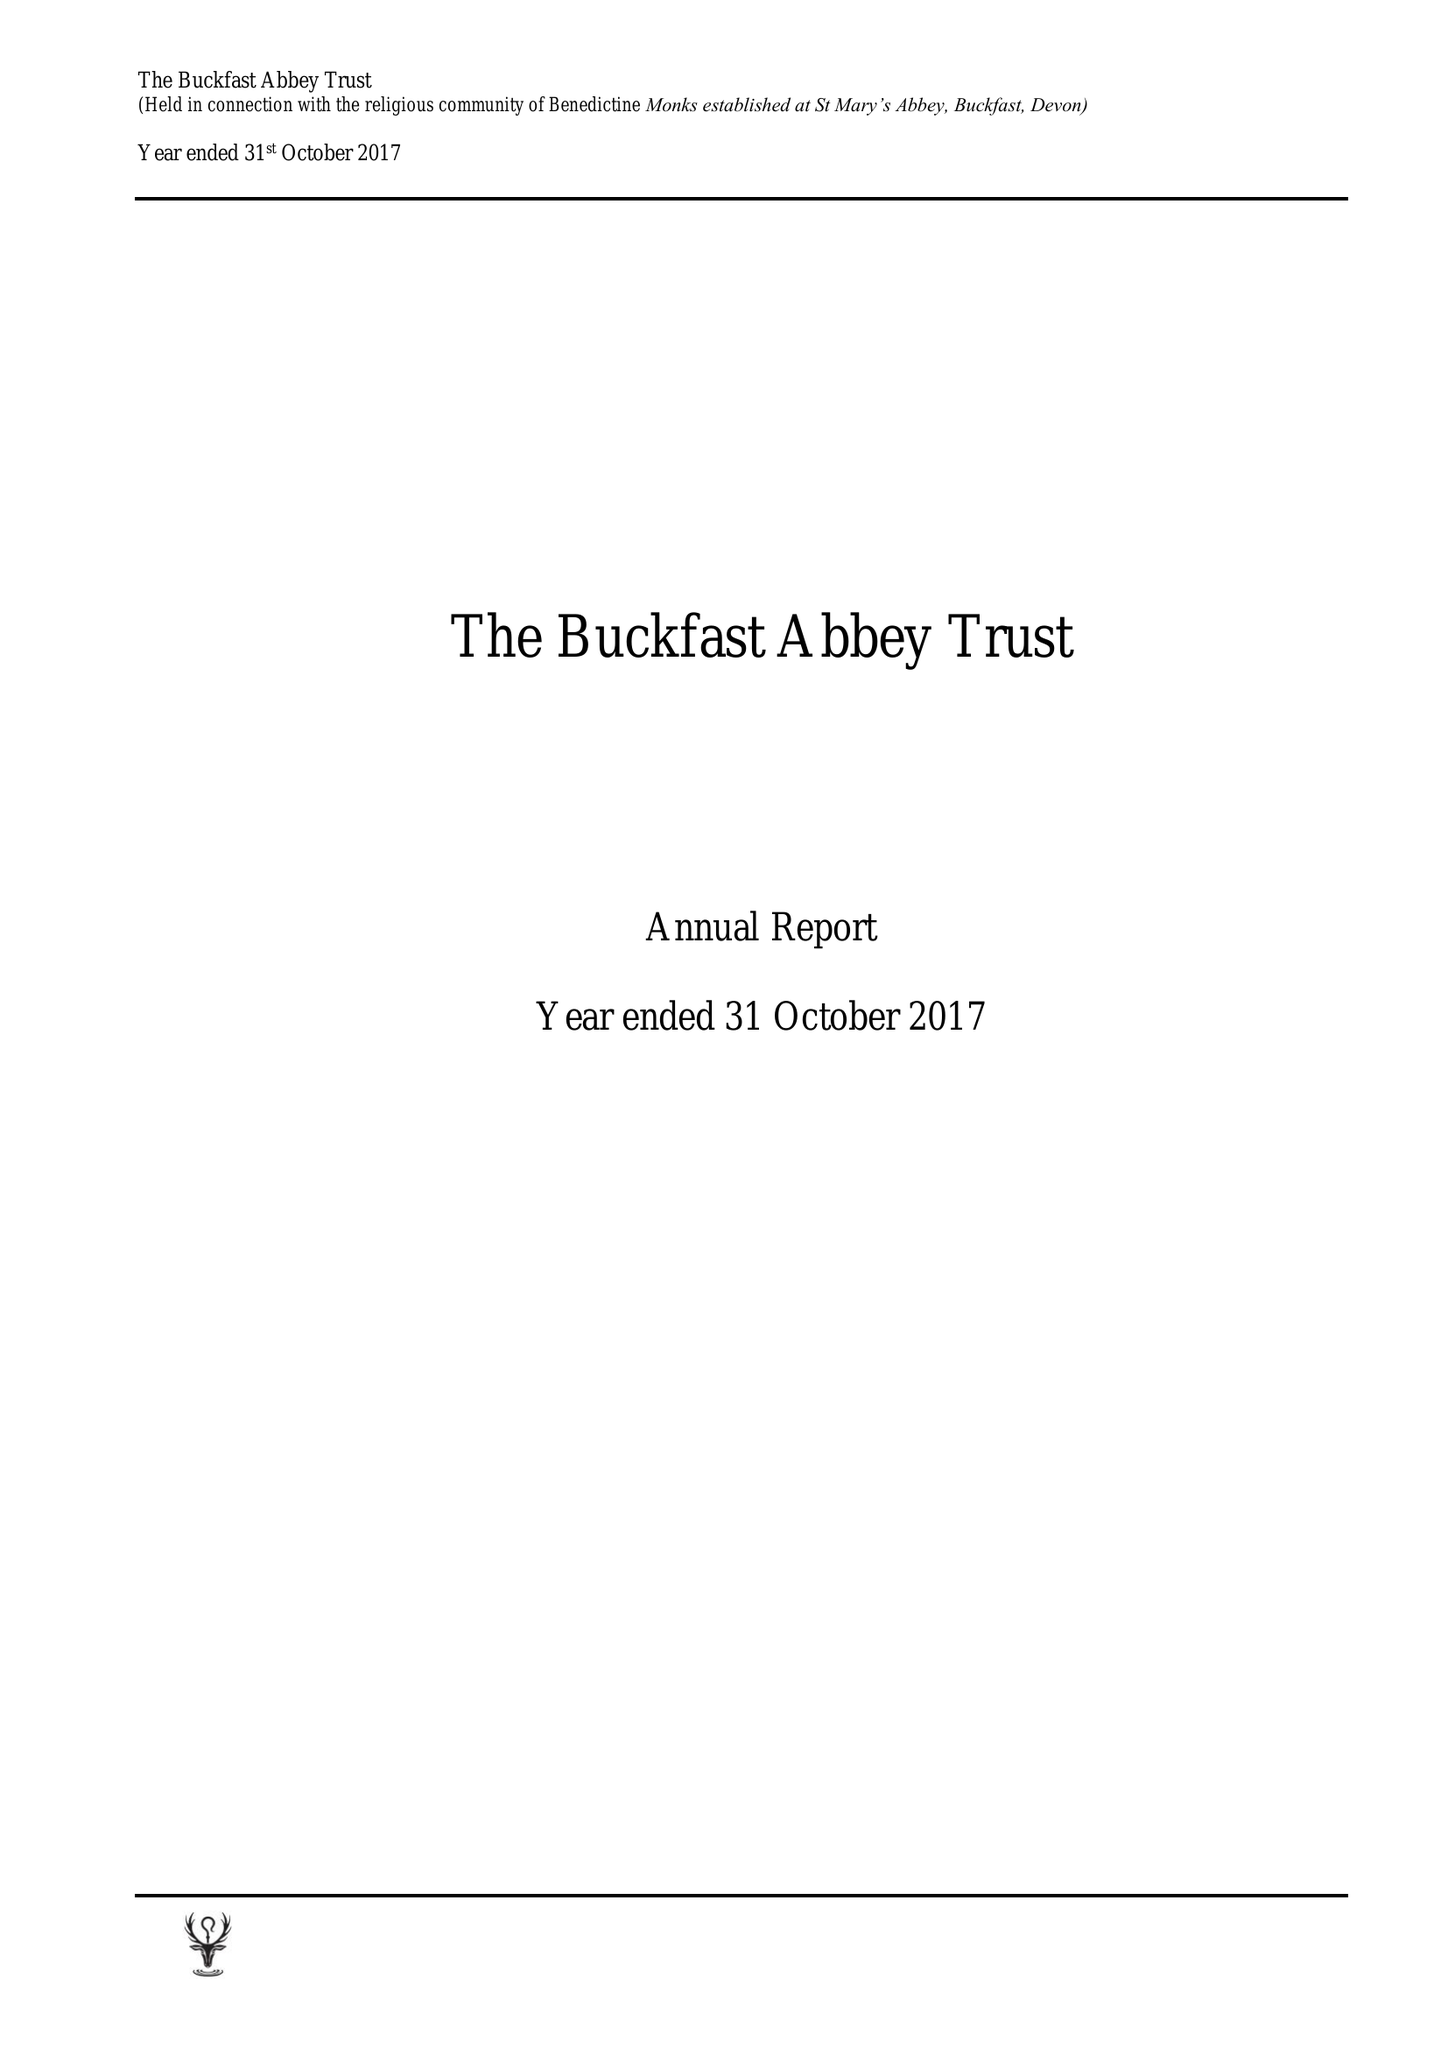What is the value for the address__postcode?
Answer the question using a single word or phrase. TQ11 0EE 